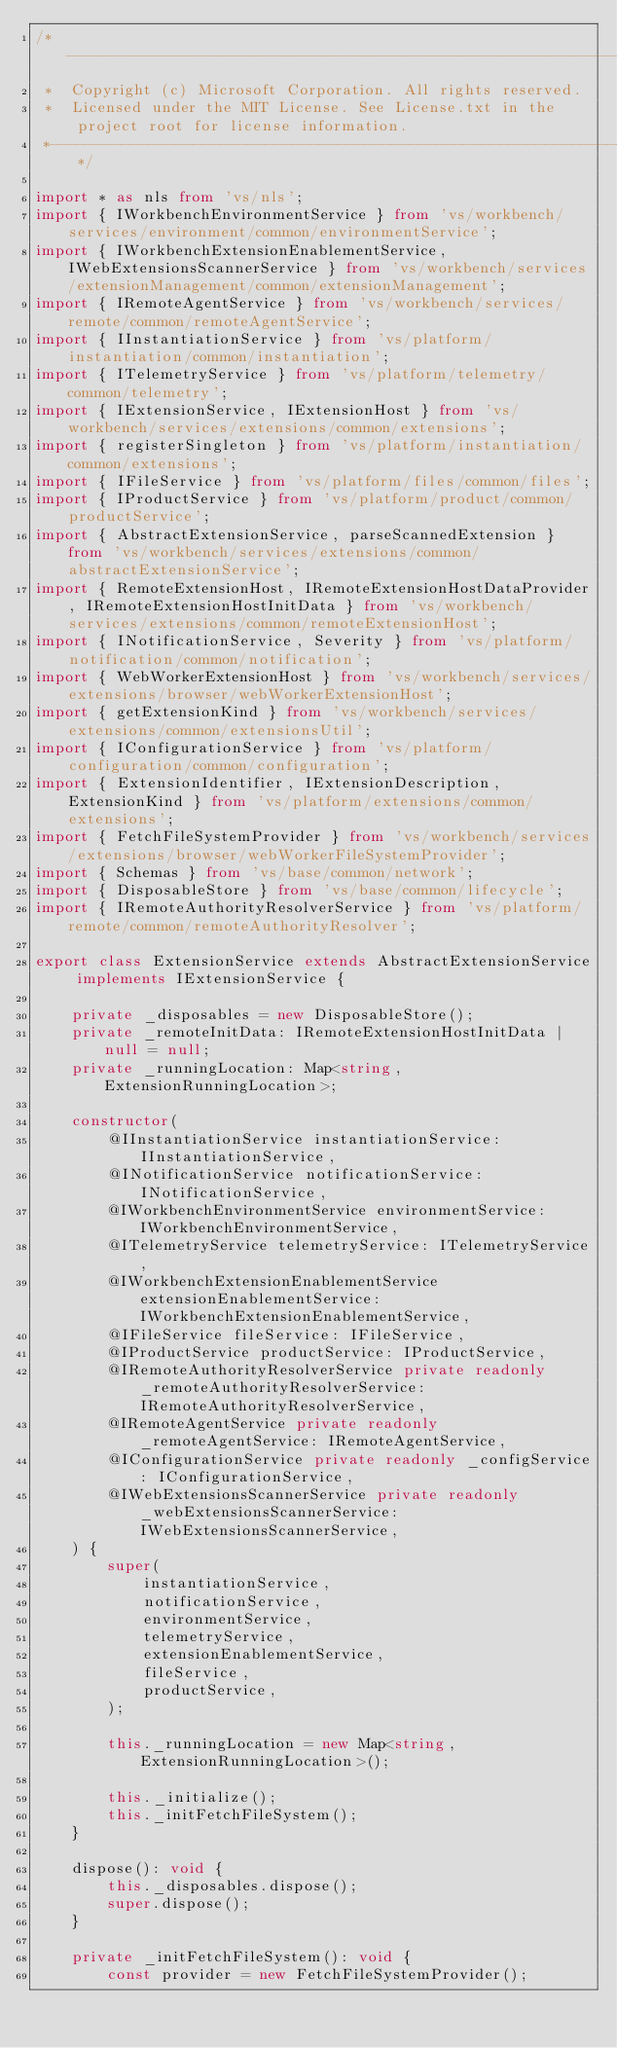<code> <loc_0><loc_0><loc_500><loc_500><_TypeScript_>/*---------------------------------------------------------------------------------------------
 *  Copyright (c) Microsoft Corporation. All rights reserved.
 *  Licensed under the MIT License. See License.txt in the project root for license information.
 *--------------------------------------------------------------------------------------------*/

import * as nls from 'vs/nls';
import { IWorkbenchEnvironmentService } from 'vs/workbench/services/environment/common/environmentService';
import { IWorkbenchExtensionEnablementService, IWebExtensionsScannerService } from 'vs/workbench/services/extensionManagement/common/extensionManagement';
import { IRemoteAgentService } from 'vs/workbench/services/remote/common/remoteAgentService';
import { IInstantiationService } from 'vs/platform/instantiation/common/instantiation';
import { ITelemetryService } from 'vs/platform/telemetry/common/telemetry';
import { IExtensionService, IExtensionHost } from 'vs/workbench/services/extensions/common/extensions';
import { registerSingleton } from 'vs/platform/instantiation/common/extensions';
import { IFileService } from 'vs/platform/files/common/files';
import { IProductService } from 'vs/platform/product/common/productService';
import { AbstractExtensionService, parseScannedExtension } from 'vs/workbench/services/extensions/common/abstractExtensionService';
import { RemoteExtensionHost, IRemoteExtensionHostDataProvider, IRemoteExtensionHostInitData } from 'vs/workbench/services/extensions/common/remoteExtensionHost';
import { INotificationService, Severity } from 'vs/platform/notification/common/notification';
import { WebWorkerExtensionHost } from 'vs/workbench/services/extensions/browser/webWorkerExtensionHost';
import { getExtensionKind } from 'vs/workbench/services/extensions/common/extensionsUtil';
import { IConfigurationService } from 'vs/platform/configuration/common/configuration';
import { ExtensionIdentifier, IExtensionDescription, ExtensionKind } from 'vs/platform/extensions/common/extensions';
import { FetchFileSystemProvider } from 'vs/workbench/services/extensions/browser/webWorkerFileSystemProvider';
import { Schemas } from 'vs/base/common/network';
import { DisposableStore } from 'vs/base/common/lifecycle';
import { IRemoteAuthorityResolverService } from 'vs/platform/remote/common/remoteAuthorityResolver';

export class ExtensionService extends AbstractExtensionService implements IExtensionService {

	private _disposables = new DisposableStore();
	private _remoteInitData: IRemoteExtensionHostInitData | null = null;
	private _runningLocation: Map<string, ExtensionRunningLocation>;

	constructor(
		@IInstantiationService instantiationService: IInstantiationService,
		@INotificationService notificationService: INotificationService,
		@IWorkbenchEnvironmentService environmentService: IWorkbenchEnvironmentService,
		@ITelemetryService telemetryService: ITelemetryService,
		@IWorkbenchExtensionEnablementService extensionEnablementService: IWorkbenchExtensionEnablementService,
		@IFileService fileService: IFileService,
		@IProductService productService: IProductService,
		@IRemoteAuthorityResolverService private readonly _remoteAuthorityResolverService: IRemoteAuthorityResolverService,
		@IRemoteAgentService private readonly _remoteAgentService: IRemoteAgentService,
		@IConfigurationService private readonly _configService: IConfigurationService,
		@IWebExtensionsScannerService private readonly _webExtensionsScannerService: IWebExtensionsScannerService,
	) {
		super(
			instantiationService,
			notificationService,
			environmentService,
			telemetryService,
			extensionEnablementService,
			fileService,
			productService,
		);

		this._runningLocation = new Map<string, ExtensionRunningLocation>();

		this._initialize();
		this._initFetchFileSystem();
	}

	dispose(): void {
		this._disposables.dispose();
		super.dispose();
	}

	private _initFetchFileSystem(): void {
		const provider = new FetchFileSystemProvider();</code> 